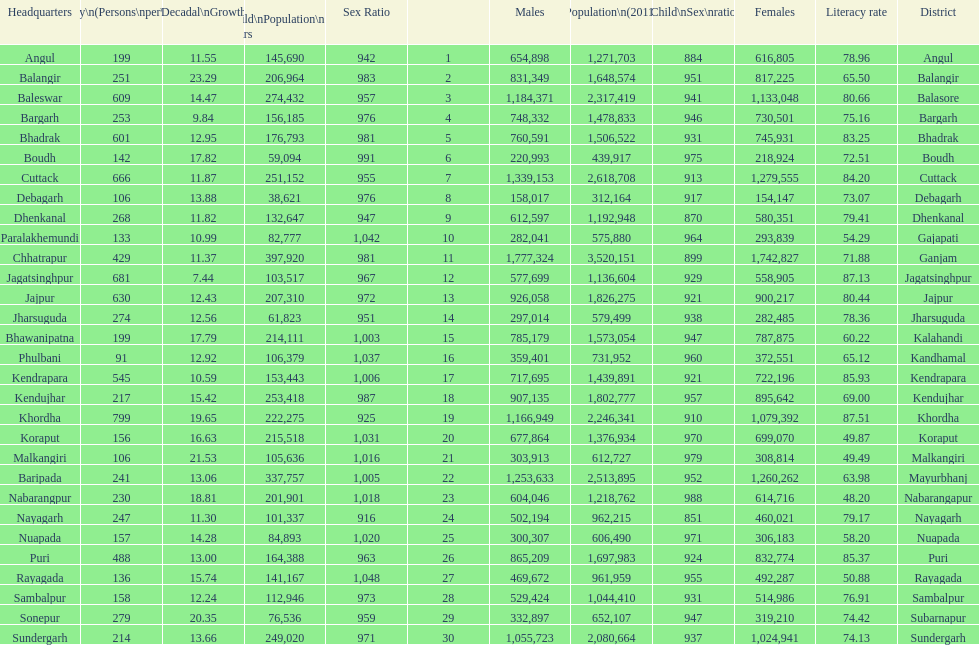Which district has a higher population, angul or cuttack? Cuttack. 